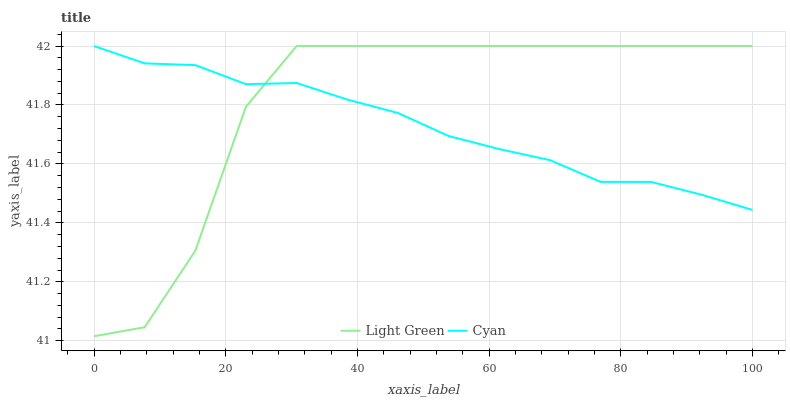Does Cyan have the minimum area under the curve?
Answer yes or no. Yes. Does Light Green have the maximum area under the curve?
Answer yes or no. Yes. Does Light Green have the minimum area under the curve?
Answer yes or no. No. Is Cyan the smoothest?
Answer yes or no. Yes. Is Light Green the roughest?
Answer yes or no. Yes. Is Light Green the smoothest?
Answer yes or no. No. Does Light Green have the lowest value?
Answer yes or no. Yes. Does Light Green have the highest value?
Answer yes or no. Yes. Does Cyan intersect Light Green?
Answer yes or no. Yes. Is Cyan less than Light Green?
Answer yes or no. No. Is Cyan greater than Light Green?
Answer yes or no. No. 